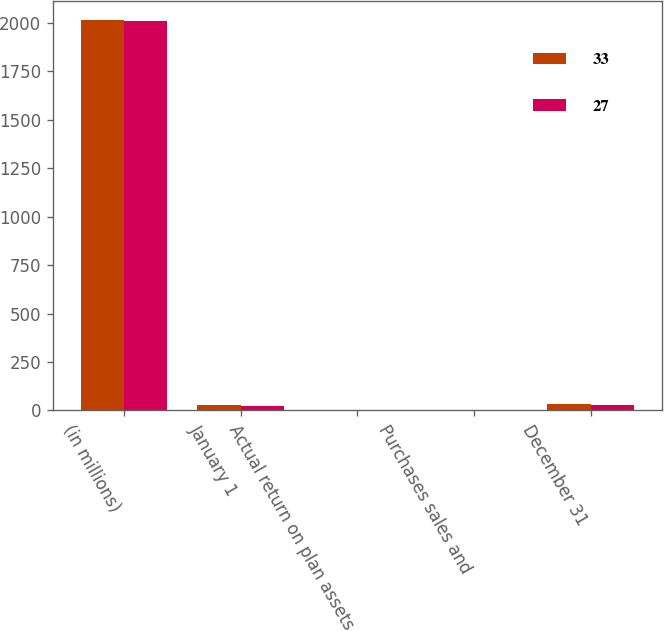<chart> <loc_0><loc_0><loc_500><loc_500><stacked_bar_chart><ecel><fcel>(in millions)<fcel>January 1<fcel>Actual return on plan assets<fcel>Purchases sales and<fcel>December 31<nl><fcel>33<fcel>2012<fcel>27<fcel>3<fcel>3<fcel>33<nl><fcel>27<fcel>2011<fcel>22<fcel>1<fcel>3<fcel>27<nl></chart> 